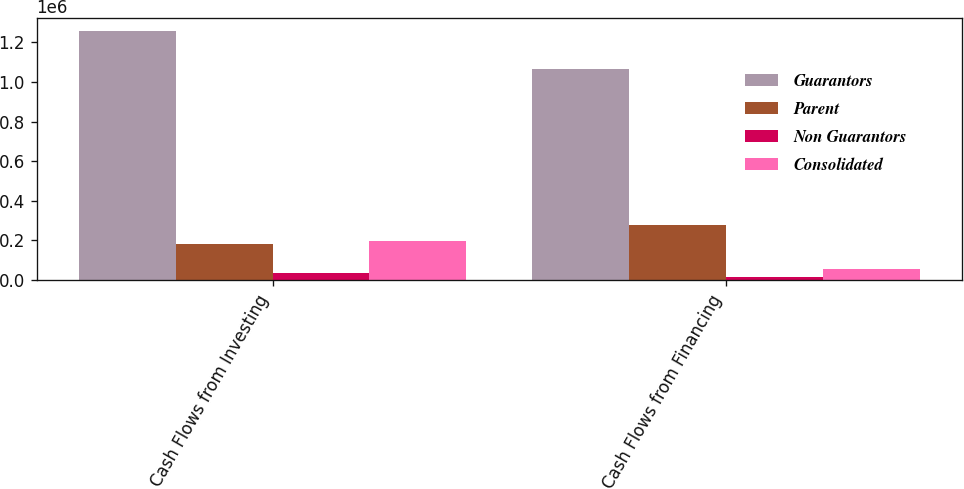Convert chart. <chart><loc_0><loc_0><loc_500><loc_500><stacked_bar_chart><ecel><fcel>Cash Flows from Investing<fcel>Cash Flows from Financing<nl><fcel>Guarantors<fcel>1.25893e+06<fcel>1.06572e+06<nl><fcel>Parent<fcel>180800<fcel>277430<nl><fcel>Non Guarantors<fcel>36162<fcel>15803<nl><fcel>Consolidated<fcel>198374<fcel>55234<nl></chart> 